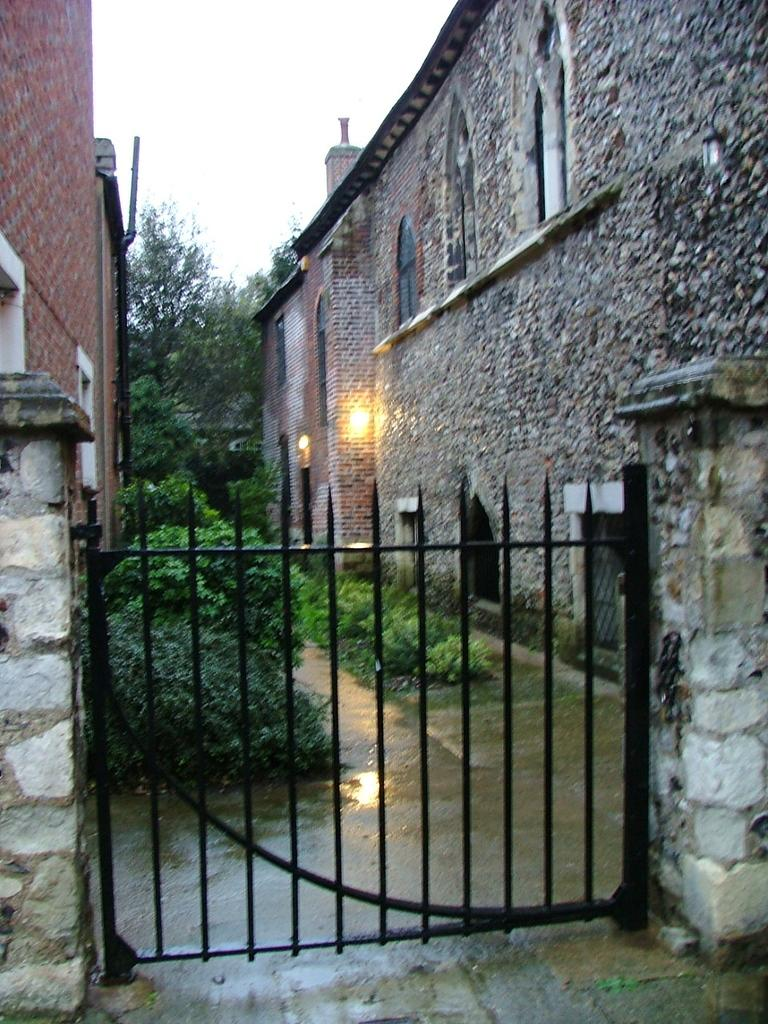What structure can be seen in the image? There is a gate in the image. What type of natural elements are present in the image? There are trees and plants in the image. What type of man-made structures can be seen in the image? There are buildings in the image. What type of illumination is visible in the image? There is light visible in the image. What part of the natural environment is visible in the image? The sky is visible in the image. How many buttons are present on the gate in the image? There are no buttons visible on the gate in the image. What type of list can be seen hanging from the trees in the image? There are no lists present in the image; only trees, plants, buildings, light, and the sky are visible. 